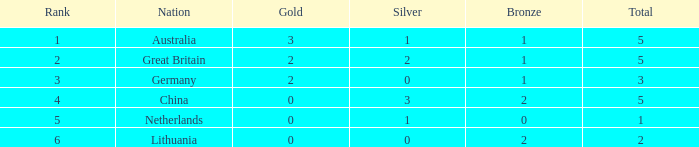What is the number for rank when gold is less than 0? None. 